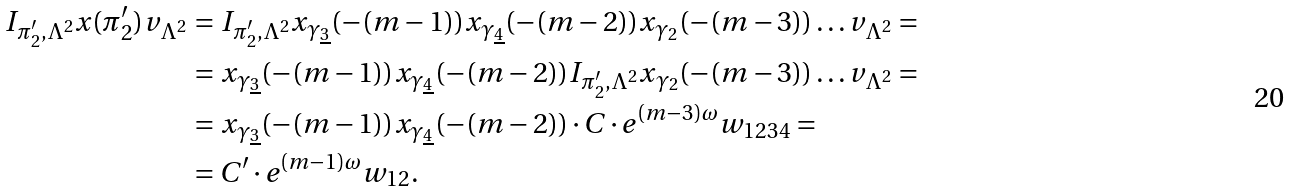Convert formula to latex. <formula><loc_0><loc_0><loc_500><loc_500>I _ { \pi _ { 2 } ^ { \prime } , \Lambda ^ { 2 } } x ( \pi _ { 2 } ^ { \prime } ) v _ { \Lambda ^ { 2 } } & = I _ { \pi _ { 2 } ^ { \prime } , \Lambda ^ { 2 } } x _ { \gamma _ { \underline { 3 } } } ( - ( m - 1 ) ) x _ { \gamma _ { \underline { 4 } } } ( - ( m - 2 ) ) x _ { \gamma _ { 2 } } ( - ( m - 3 ) ) \dots v _ { \Lambda ^ { 2 } } = \\ & = x _ { \gamma _ { \underline { 3 } } } ( - ( m - 1 ) ) x _ { \gamma _ { \underline { 4 } } } ( - ( m - 2 ) ) I _ { \pi _ { 2 } ^ { \prime } , \Lambda ^ { 2 } } x _ { \gamma _ { 2 } } ( - ( m - 3 ) ) \dots v _ { \Lambda ^ { 2 } } = \\ & = x _ { \gamma _ { \underline { 3 } } } ( - ( m - 1 ) ) x _ { \gamma _ { \underline { 4 } } } ( - ( m - 2 ) ) \cdot C \cdot e ^ { ( m - 3 ) \omega } w _ { 1 2 3 4 } = \\ & = C ^ { \prime } \cdot e ^ { ( m - 1 ) \omega } w _ { 1 2 } .</formula> 